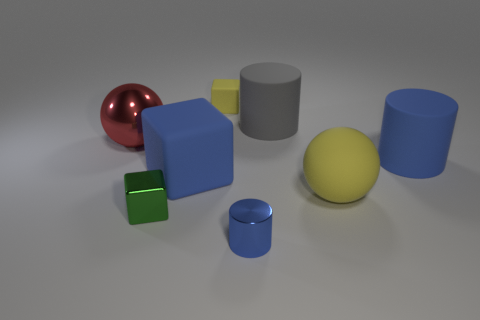Is the shape of the yellow matte thing that is behind the gray rubber thing the same as  the gray matte object?
Keep it short and to the point. No. Are there more blue rubber objects that are on the left side of the small shiny cylinder than large blue rubber objects?
Keep it short and to the point. No. Is there anything else that is made of the same material as the big gray thing?
Keep it short and to the point. Yes. The matte thing that is the same color as the tiny rubber block is what shape?
Offer a very short reply. Sphere. How many balls are either big yellow things or blue things?
Ensure brevity in your answer.  1. There is a large matte ball in front of the rubber cylinder that is on the right side of the large yellow rubber ball; what color is it?
Make the answer very short. Yellow. Is the color of the metallic cylinder the same as the ball behind the big yellow thing?
Provide a short and direct response. No. What is the size of the other yellow object that is the same material as the large yellow object?
Ensure brevity in your answer.  Small. There is a matte cylinder that is the same color as the metal cylinder; what size is it?
Your answer should be very brief. Large. Does the tiny rubber thing have the same color as the metal cylinder?
Give a very brief answer. No. 